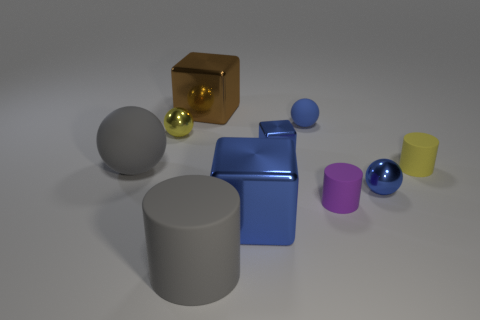What number of brown objects are either small cubes or tiny matte cylinders?
Provide a succinct answer. 0. Do the brown metallic object and the large blue thing have the same shape?
Your answer should be very brief. Yes. Is there a tiny metal ball in front of the tiny thing that is on the left side of the brown metal thing?
Provide a short and direct response. Yes. Are there the same number of big matte balls that are to the right of the purple rubber object and small red metallic cubes?
Your response must be concise. Yes. What number of other things are there of the same size as the yellow sphere?
Keep it short and to the point. 5. Does the large cube in front of the blue matte ball have the same material as the large gray object that is on the right side of the brown metallic object?
Your answer should be very brief. No. There is a yellow object to the right of the gray matte thing in front of the large ball; how big is it?
Provide a short and direct response. Small. Is there a tiny cylinder of the same color as the big matte cylinder?
Ensure brevity in your answer.  No. Is the color of the matte ball that is to the left of the tiny block the same as the large cylinder that is to the left of the big blue metallic object?
Give a very brief answer. Yes. What is the shape of the brown metallic thing?
Provide a short and direct response. Cube. 